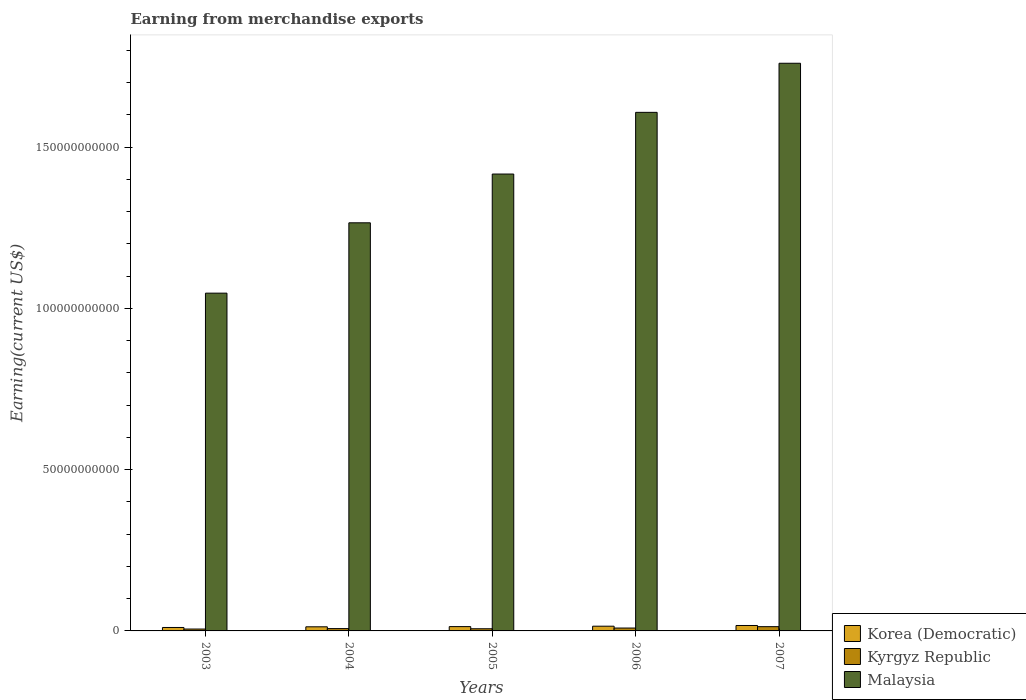How many groups of bars are there?
Provide a succinct answer. 5. Are the number of bars per tick equal to the number of legend labels?
Ensure brevity in your answer.  Yes. How many bars are there on the 1st tick from the left?
Offer a terse response. 3. What is the amount earned from merchandise exports in Korea (Democratic) in 2004?
Your answer should be compact. 1.28e+09. Across all years, what is the maximum amount earned from merchandise exports in Malaysia?
Make the answer very short. 1.76e+11. Across all years, what is the minimum amount earned from merchandise exports in Malaysia?
Your response must be concise. 1.05e+11. In which year was the amount earned from merchandise exports in Korea (Democratic) maximum?
Your answer should be very brief. 2007. In which year was the amount earned from merchandise exports in Malaysia minimum?
Your answer should be very brief. 2003. What is the total amount earned from merchandise exports in Korea (Democratic) in the graph?
Make the answer very short. 6.83e+09. What is the difference between the amount earned from merchandise exports in Malaysia in 2006 and that in 2007?
Provide a short and direct response. -1.52e+1. What is the difference between the amount earned from merchandise exports in Korea (Democratic) in 2005 and the amount earned from merchandise exports in Kyrgyz Republic in 2004?
Make the answer very short. 6.19e+08. What is the average amount earned from merchandise exports in Kyrgyz Republic per year?
Make the answer very short. 8.37e+08. In the year 2004, what is the difference between the amount earned from merchandise exports in Korea (Democratic) and amount earned from merchandise exports in Kyrgyz Republic?
Make the answer very short. 5.59e+08. What is the ratio of the amount earned from merchandise exports in Kyrgyz Republic in 2005 to that in 2007?
Keep it short and to the point. 0.51. Is the amount earned from merchandise exports in Korea (Democratic) in 2003 less than that in 2006?
Your response must be concise. Yes. Is the difference between the amount earned from merchandise exports in Korea (Democratic) in 2003 and 2007 greater than the difference between the amount earned from merchandise exports in Kyrgyz Republic in 2003 and 2007?
Provide a succinct answer. Yes. What is the difference between the highest and the second highest amount earned from merchandise exports in Korea (Democratic)?
Your answer should be very brief. 2.20e+08. What is the difference between the highest and the lowest amount earned from merchandise exports in Korea (Democratic)?
Offer a very short reply. 6.19e+08. In how many years, is the amount earned from merchandise exports in Kyrgyz Republic greater than the average amount earned from merchandise exports in Kyrgyz Republic taken over all years?
Give a very brief answer. 2. What does the 1st bar from the left in 2003 represents?
Your answer should be compact. Korea (Democratic). What does the 3rd bar from the right in 2005 represents?
Your answer should be very brief. Korea (Democratic). How many bars are there?
Your response must be concise. 15. Are all the bars in the graph horizontal?
Provide a succinct answer. No. Are the values on the major ticks of Y-axis written in scientific E-notation?
Keep it short and to the point. No. Does the graph contain any zero values?
Keep it short and to the point. No. What is the title of the graph?
Provide a short and direct response. Earning from merchandise exports. Does "Turks and Caicos Islands" appear as one of the legend labels in the graph?
Make the answer very short. No. What is the label or title of the X-axis?
Provide a short and direct response. Years. What is the label or title of the Y-axis?
Provide a succinct answer. Earning(current US$). What is the Earning(current US$) in Korea (Democratic) in 2003?
Your answer should be compact. 1.07e+09. What is the Earning(current US$) in Kyrgyz Republic in 2003?
Keep it short and to the point. 5.82e+08. What is the Earning(current US$) in Malaysia in 2003?
Give a very brief answer. 1.05e+11. What is the Earning(current US$) of Korea (Democratic) in 2004?
Offer a very short reply. 1.28e+09. What is the Earning(current US$) in Kyrgyz Republic in 2004?
Ensure brevity in your answer.  7.19e+08. What is the Earning(current US$) in Malaysia in 2004?
Provide a succinct answer. 1.27e+11. What is the Earning(current US$) in Korea (Democratic) in 2005?
Your answer should be compact. 1.34e+09. What is the Earning(current US$) in Kyrgyz Republic in 2005?
Your response must be concise. 6.72e+08. What is the Earning(current US$) in Malaysia in 2005?
Ensure brevity in your answer.  1.42e+11. What is the Earning(current US$) in Korea (Democratic) in 2006?
Offer a very short reply. 1.46e+09. What is the Earning(current US$) in Kyrgyz Republic in 2006?
Make the answer very short. 8.91e+08. What is the Earning(current US$) in Malaysia in 2006?
Offer a very short reply. 1.61e+11. What is the Earning(current US$) of Korea (Democratic) in 2007?
Give a very brief answer. 1.68e+09. What is the Earning(current US$) in Kyrgyz Republic in 2007?
Your answer should be compact. 1.32e+09. What is the Earning(current US$) in Malaysia in 2007?
Ensure brevity in your answer.  1.76e+11. Across all years, what is the maximum Earning(current US$) of Korea (Democratic)?
Keep it short and to the point. 1.68e+09. Across all years, what is the maximum Earning(current US$) in Kyrgyz Republic?
Provide a short and direct response. 1.32e+09. Across all years, what is the maximum Earning(current US$) of Malaysia?
Provide a short and direct response. 1.76e+11. Across all years, what is the minimum Earning(current US$) of Korea (Democratic)?
Offer a very short reply. 1.07e+09. Across all years, what is the minimum Earning(current US$) of Kyrgyz Republic?
Provide a short and direct response. 5.82e+08. Across all years, what is the minimum Earning(current US$) in Malaysia?
Give a very brief answer. 1.05e+11. What is the total Earning(current US$) of Korea (Democratic) in the graph?
Offer a very short reply. 6.83e+09. What is the total Earning(current US$) of Kyrgyz Republic in the graph?
Offer a terse response. 4.18e+09. What is the total Earning(current US$) in Malaysia in the graph?
Your answer should be compact. 7.10e+11. What is the difference between the Earning(current US$) in Korea (Democratic) in 2003 and that in 2004?
Provide a succinct answer. -2.12e+08. What is the difference between the Earning(current US$) in Kyrgyz Republic in 2003 and that in 2004?
Offer a terse response. -1.37e+08. What is the difference between the Earning(current US$) of Malaysia in 2003 and that in 2004?
Provide a short and direct response. -2.18e+1. What is the difference between the Earning(current US$) in Korea (Democratic) in 2003 and that in 2005?
Provide a succinct answer. -2.72e+08. What is the difference between the Earning(current US$) in Kyrgyz Republic in 2003 and that in 2005?
Your answer should be compact. -9.03e+07. What is the difference between the Earning(current US$) of Malaysia in 2003 and that in 2005?
Provide a short and direct response. -3.69e+1. What is the difference between the Earning(current US$) in Korea (Democratic) in 2003 and that in 2006?
Your answer should be compact. -3.99e+08. What is the difference between the Earning(current US$) in Kyrgyz Republic in 2003 and that in 2006?
Keep it short and to the point. -3.09e+08. What is the difference between the Earning(current US$) of Malaysia in 2003 and that in 2006?
Ensure brevity in your answer.  -5.60e+1. What is the difference between the Earning(current US$) of Korea (Democratic) in 2003 and that in 2007?
Ensure brevity in your answer.  -6.19e+08. What is the difference between the Earning(current US$) of Kyrgyz Republic in 2003 and that in 2007?
Keep it short and to the point. -7.39e+08. What is the difference between the Earning(current US$) of Malaysia in 2003 and that in 2007?
Provide a short and direct response. -7.13e+1. What is the difference between the Earning(current US$) of Korea (Democratic) in 2004 and that in 2005?
Ensure brevity in your answer.  -6.00e+07. What is the difference between the Earning(current US$) in Kyrgyz Republic in 2004 and that in 2005?
Offer a very short reply. 4.68e+07. What is the difference between the Earning(current US$) of Malaysia in 2004 and that in 2005?
Make the answer very short. -1.51e+1. What is the difference between the Earning(current US$) of Korea (Democratic) in 2004 and that in 2006?
Give a very brief answer. -1.87e+08. What is the difference between the Earning(current US$) of Kyrgyz Republic in 2004 and that in 2006?
Ensure brevity in your answer.  -1.72e+08. What is the difference between the Earning(current US$) in Malaysia in 2004 and that in 2006?
Give a very brief answer. -3.42e+1. What is the difference between the Earning(current US$) of Korea (Democratic) in 2004 and that in 2007?
Ensure brevity in your answer.  -4.07e+08. What is the difference between the Earning(current US$) in Kyrgyz Republic in 2004 and that in 2007?
Ensure brevity in your answer.  -6.02e+08. What is the difference between the Earning(current US$) of Malaysia in 2004 and that in 2007?
Make the answer very short. -4.95e+1. What is the difference between the Earning(current US$) of Korea (Democratic) in 2005 and that in 2006?
Offer a terse response. -1.27e+08. What is the difference between the Earning(current US$) of Kyrgyz Republic in 2005 and that in 2006?
Ensure brevity in your answer.  -2.19e+08. What is the difference between the Earning(current US$) in Malaysia in 2005 and that in 2006?
Your response must be concise. -1.91e+1. What is the difference between the Earning(current US$) in Korea (Democratic) in 2005 and that in 2007?
Your response must be concise. -3.47e+08. What is the difference between the Earning(current US$) of Kyrgyz Republic in 2005 and that in 2007?
Offer a very short reply. -6.49e+08. What is the difference between the Earning(current US$) of Malaysia in 2005 and that in 2007?
Make the answer very short. -3.43e+1. What is the difference between the Earning(current US$) of Korea (Democratic) in 2006 and that in 2007?
Ensure brevity in your answer.  -2.20e+08. What is the difference between the Earning(current US$) of Kyrgyz Republic in 2006 and that in 2007?
Your answer should be very brief. -4.30e+08. What is the difference between the Earning(current US$) in Malaysia in 2006 and that in 2007?
Give a very brief answer. -1.52e+1. What is the difference between the Earning(current US$) of Korea (Democratic) in 2003 and the Earning(current US$) of Kyrgyz Republic in 2004?
Offer a very short reply. 3.47e+08. What is the difference between the Earning(current US$) in Korea (Democratic) in 2003 and the Earning(current US$) in Malaysia in 2004?
Provide a succinct answer. -1.25e+11. What is the difference between the Earning(current US$) in Kyrgyz Republic in 2003 and the Earning(current US$) in Malaysia in 2004?
Your response must be concise. -1.26e+11. What is the difference between the Earning(current US$) of Korea (Democratic) in 2003 and the Earning(current US$) of Kyrgyz Republic in 2005?
Your answer should be compact. 3.94e+08. What is the difference between the Earning(current US$) in Korea (Democratic) in 2003 and the Earning(current US$) in Malaysia in 2005?
Offer a terse response. -1.41e+11. What is the difference between the Earning(current US$) of Kyrgyz Republic in 2003 and the Earning(current US$) of Malaysia in 2005?
Provide a short and direct response. -1.41e+11. What is the difference between the Earning(current US$) of Korea (Democratic) in 2003 and the Earning(current US$) of Kyrgyz Republic in 2006?
Your answer should be compact. 1.75e+08. What is the difference between the Earning(current US$) of Korea (Democratic) in 2003 and the Earning(current US$) of Malaysia in 2006?
Keep it short and to the point. -1.60e+11. What is the difference between the Earning(current US$) in Kyrgyz Republic in 2003 and the Earning(current US$) in Malaysia in 2006?
Ensure brevity in your answer.  -1.60e+11. What is the difference between the Earning(current US$) in Korea (Democratic) in 2003 and the Earning(current US$) in Kyrgyz Republic in 2007?
Provide a succinct answer. -2.55e+08. What is the difference between the Earning(current US$) in Korea (Democratic) in 2003 and the Earning(current US$) in Malaysia in 2007?
Provide a short and direct response. -1.75e+11. What is the difference between the Earning(current US$) of Kyrgyz Republic in 2003 and the Earning(current US$) of Malaysia in 2007?
Your answer should be very brief. -1.75e+11. What is the difference between the Earning(current US$) in Korea (Democratic) in 2004 and the Earning(current US$) in Kyrgyz Republic in 2005?
Provide a short and direct response. 6.06e+08. What is the difference between the Earning(current US$) of Korea (Democratic) in 2004 and the Earning(current US$) of Malaysia in 2005?
Make the answer very short. -1.40e+11. What is the difference between the Earning(current US$) in Kyrgyz Republic in 2004 and the Earning(current US$) in Malaysia in 2005?
Keep it short and to the point. -1.41e+11. What is the difference between the Earning(current US$) of Korea (Democratic) in 2004 and the Earning(current US$) of Kyrgyz Republic in 2006?
Give a very brief answer. 3.87e+08. What is the difference between the Earning(current US$) in Korea (Democratic) in 2004 and the Earning(current US$) in Malaysia in 2006?
Ensure brevity in your answer.  -1.59e+11. What is the difference between the Earning(current US$) of Kyrgyz Republic in 2004 and the Earning(current US$) of Malaysia in 2006?
Make the answer very short. -1.60e+11. What is the difference between the Earning(current US$) of Korea (Democratic) in 2004 and the Earning(current US$) of Kyrgyz Republic in 2007?
Ensure brevity in your answer.  -4.31e+07. What is the difference between the Earning(current US$) in Korea (Democratic) in 2004 and the Earning(current US$) in Malaysia in 2007?
Offer a terse response. -1.75e+11. What is the difference between the Earning(current US$) of Kyrgyz Republic in 2004 and the Earning(current US$) of Malaysia in 2007?
Ensure brevity in your answer.  -1.75e+11. What is the difference between the Earning(current US$) in Korea (Democratic) in 2005 and the Earning(current US$) in Kyrgyz Republic in 2006?
Provide a short and direct response. 4.47e+08. What is the difference between the Earning(current US$) of Korea (Democratic) in 2005 and the Earning(current US$) of Malaysia in 2006?
Your answer should be very brief. -1.59e+11. What is the difference between the Earning(current US$) in Kyrgyz Republic in 2005 and the Earning(current US$) in Malaysia in 2006?
Your answer should be very brief. -1.60e+11. What is the difference between the Earning(current US$) of Korea (Democratic) in 2005 and the Earning(current US$) of Kyrgyz Republic in 2007?
Provide a short and direct response. 1.69e+07. What is the difference between the Earning(current US$) of Korea (Democratic) in 2005 and the Earning(current US$) of Malaysia in 2007?
Your answer should be very brief. -1.75e+11. What is the difference between the Earning(current US$) of Kyrgyz Republic in 2005 and the Earning(current US$) of Malaysia in 2007?
Offer a terse response. -1.75e+11. What is the difference between the Earning(current US$) in Korea (Democratic) in 2006 and the Earning(current US$) in Kyrgyz Republic in 2007?
Offer a very short reply. 1.44e+08. What is the difference between the Earning(current US$) of Korea (Democratic) in 2006 and the Earning(current US$) of Malaysia in 2007?
Keep it short and to the point. -1.75e+11. What is the difference between the Earning(current US$) in Kyrgyz Republic in 2006 and the Earning(current US$) in Malaysia in 2007?
Offer a very short reply. -1.75e+11. What is the average Earning(current US$) of Korea (Democratic) per year?
Provide a succinct answer. 1.37e+09. What is the average Earning(current US$) in Kyrgyz Republic per year?
Your response must be concise. 8.37e+08. What is the average Earning(current US$) in Malaysia per year?
Give a very brief answer. 1.42e+11. In the year 2003, what is the difference between the Earning(current US$) of Korea (Democratic) and Earning(current US$) of Kyrgyz Republic?
Your answer should be very brief. 4.84e+08. In the year 2003, what is the difference between the Earning(current US$) in Korea (Democratic) and Earning(current US$) in Malaysia?
Your response must be concise. -1.04e+11. In the year 2003, what is the difference between the Earning(current US$) in Kyrgyz Republic and Earning(current US$) in Malaysia?
Your response must be concise. -1.04e+11. In the year 2004, what is the difference between the Earning(current US$) of Korea (Democratic) and Earning(current US$) of Kyrgyz Republic?
Your answer should be compact. 5.59e+08. In the year 2004, what is the difference between the Earning(current US$) of Korea (Democratic) and Earning(current US$) of Malaysia?
Ensure brevity in your answer.  -1.25e+11. In the year 2004, what is the difference between the Earning(current US$) of Kyrgyz Republic and Earning(current US$) of Malaysia?
Your response must be concise. -1.26e+11. In the year 2005, what is the difference between the Earning(current US$) in Korea (Democratic) and Earning(current US$) in Kyrgyz Republic?
Your response must be concise. 6.66e+08. In the year 2005, what is the difference between the Earning(current US$) in Korea (Democratic) and Earning(current US$) in Malaysia?
Give a very brief answer. -1.40e+11. In the year 2005, what is the difference between the Earning(current US$) in Kyrgyz Republic and Earning(current US$) in Malaysia?
Keep it short and to the point. -1.41e+11. In the year 2006, what is the difference between the Earning(current US$) of Korea (Democratic) and Earning(current US$) of Kyrgyz Republic?
Your response must be concise. 5.74e+08. In the year 2006, what is the difference between the Earning(current US$) of Korea (Democratic) and Earning(current US$) of Malaysia?
Provide a succinct answer. -1.59e+11. In the year 2006, what is the difference between the Earning(current US$) in Kyrgyz Republic and Earning(current US$) in Malaysia?
Your answer should be very brief. -1.60e+11. In the year 2007, what is the difference between the Earning(current US$) in Korea (Democratic) and Earning(current US$) in Kyrgyz Republic?
Provide a succinct answer. 3.64e+08. In the year 2007, what is the difference between the Earning(current US$) of Korea (Democratic) and Earning(current US$) of Malaysia?
Ensure brevity in your answer.  -1.74e+11. In the year 2007, what is the difference between the Earning(current US$) in Kyrgyz Republic and Earning(current US$) in Malaysia?
Your answer should be compact. -1.75e+11. What is the ratio of the Earning(current US$) in Korea (Democratic) in 2003 to that in 2004?
Offer a terse response. 0.83. What is the ratio of the Earning(current US$) of Kyrgyz Republic in 2003 to that in 2004?
Give a very brief answer. 0.81. What is the ratio of the Earning(current US$) of Malaysia in 2003 to that in 2004?
Ensure brevity in your answer.  0.83. What is the ratio of the Earning(current US$) of Korea (Democratic) in 2003 to that in 2005?
Keep it short and to the point. 0.8. What is the ratio of the Earning(current US$) of Kyrgyz Republic in 2003 to that in 2005?
Offer a very short reply. 0.87. What is the ratio of the Earning(current US$) in Malaysia in 2003 to that in 2005?
Keep it short and to the point. 0.74. What is the ratio of the Earning(current US$) in Korea (Democratic) in 2003 to that in 2006?
Your answer should be very brief. 0.73. What is the ratio of the Earning(current US$) of Kyrgyz Republic in 2003 to that in 2006?
Provide a short and direct response. 0.65. What is the ratio of the Earning(current US$) of Malaysia in 2003 to that in 2006?
Provide a short and direct response. 0.65. What is the ratio of the Earning(current US$) of Korea (Democratic) in 2003 to that in 2007?
Offer a very short reply. 0.63. What is the ratio of the Earning(current US$) in Kyrgyz Republic in 2003 to that in 2007?
Offer a very short reply. 0.44. What is the ratio of the Earning(current US$) in Malaysia in 2003 to that in 2007?
Provide a short and direct response. 0.59. What is the ratio of the Earning(current US$) of Korea (Democratic) in 2004 to that in 2005?
Offer a very short reply. 0.96. What is the ratio of the Earning(current US$) of Kyrgyz Republic in 2004 to that in 2005?
Provide a short and direct response. 1.07. What is the ratio of the Earning(current US$) in Malaysia in 2004 to that in 2005?
Provide a short and direct response. 0.89. What is the ratio of the Earning(current US$) of Korea (Democratic) in 2004 to that in 2006?
Your response must be concise. 0.87. What is the ratio of the Earning(current US$) of Kyrgyz Republic in 2004 to that in 2006?
Your answer should be compact. 0.81. What is the ratio of the Earning(current US$) in Malaysia in 2004 to that in 2006?
Keep it short and to the point. 0.79. What is the ratio of the Earning(current US$) in Korea (Democratic) in 2004 to that in 2007?
Your answer should be compact. 0.76. What is the ratio of the Earning(current US$) in Kyrgyz Republic in 2004 to that in 2007?
Keep it short and to the point. 0.54. What is the ratio of the Earning(current US$) of Malaysia in 2004 to that in 2007?
Your answer should be compact. 0.72. What is the ratio of the Earning(current US$) of Korea (Democratic) in 2005 to that in 2006?
Give a very brief answer. 0.91. What is the ratio of the Earning(current US$) in Kyrgyz Republic in 2005 to that in 2006?
Your response must be concise. 0.75. What is the ratio of the Earning(current US$) in Malaysia in 2005 to that in 2006?
Offer a very short reply. 0.88. What is the ratio of the Earning(current US$) of Korea (Democratic) in 2005 to that in 2007?
Offer a terse response. 0.79. What is the ratio of the Earning(current US$) in Kyrgyz Republic in 2005 to that in 2007?
Give a very brief answer. 0.51. What is the ratio of the Earning(current US$) in Malaysia in 2005 to that in 2007?
Make the answer very short. 0.8. What is the ratio of the Earning(current US$) of Korea (Democratic) in 2006 to that in 2007?
Your answer should be compact. 0.87. What is the ratio of the Earning(current US$) of Kyrgyz Republic in 2006 to that in 2007?
Your response must be concise. 0.67. What is the ratio of the Earning(current US$) in Malaysia in 2006 to that in 2007?
Ensure brevity in your answer.  0.91. What is the difference between the highest and the second highest Earning(current US$) of Korea (Democratic)?
Offer a very short reply. 2.20e+08. What is the difference between the highest and the second highest Earning(current US$) of Kyrgyz Republic?
Offer a very short reply. 4.30e+08. What is the difference between the highest and the second highest Earning(current US$) of Malaysia?
Provide a short and direct response. 1.52e+1. What is the difference between the highest and the lowest Earning(current US$) of Korea (Democratic)?
Your response must be concise. 6.19e+08. What is the difference between the highest and the lowest Earning(current US$) in Kyrgyz Republic?
Keep it short and to the point. 7.39e+08. What is the difference between the highest and the lowest Earning(current US$) in Malaysia?
Offer a very short reply. 7.13e+1. 